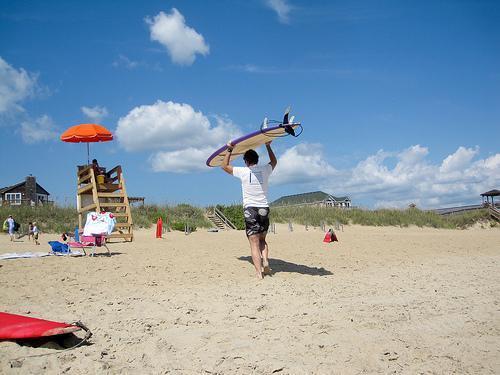How many surfboards seen in the photo?
Give a very brief answer. 2. 